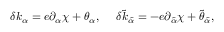<formula> <loc_0><loc_0><loc_500><loc_500>\delta k _ { \alpha } = e \partial _ { \alpha } \chi + \theta _ { \alpha } , \quad \delta \tilde { k } _ { \tilde { \alpha } } = - e \partial _ { \tilde { \alpha } } \chi + \tilde { \theta } _ { \tilde { \alpha } } ,</formula> 